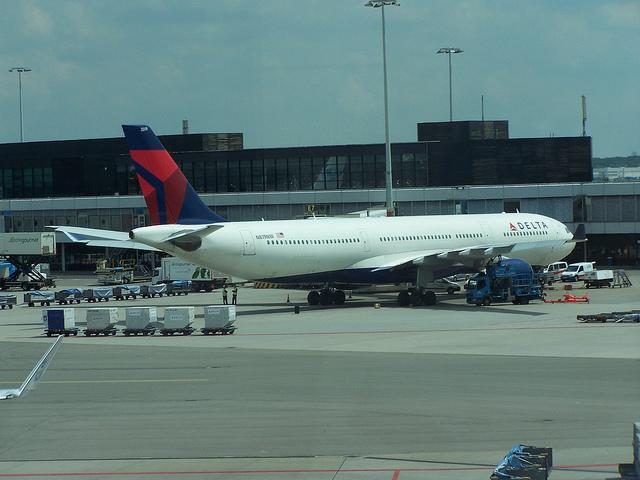Which country does this aircraft brand originate from?

Choices:
A) canada
B) america
C) chile
D) mexico america 